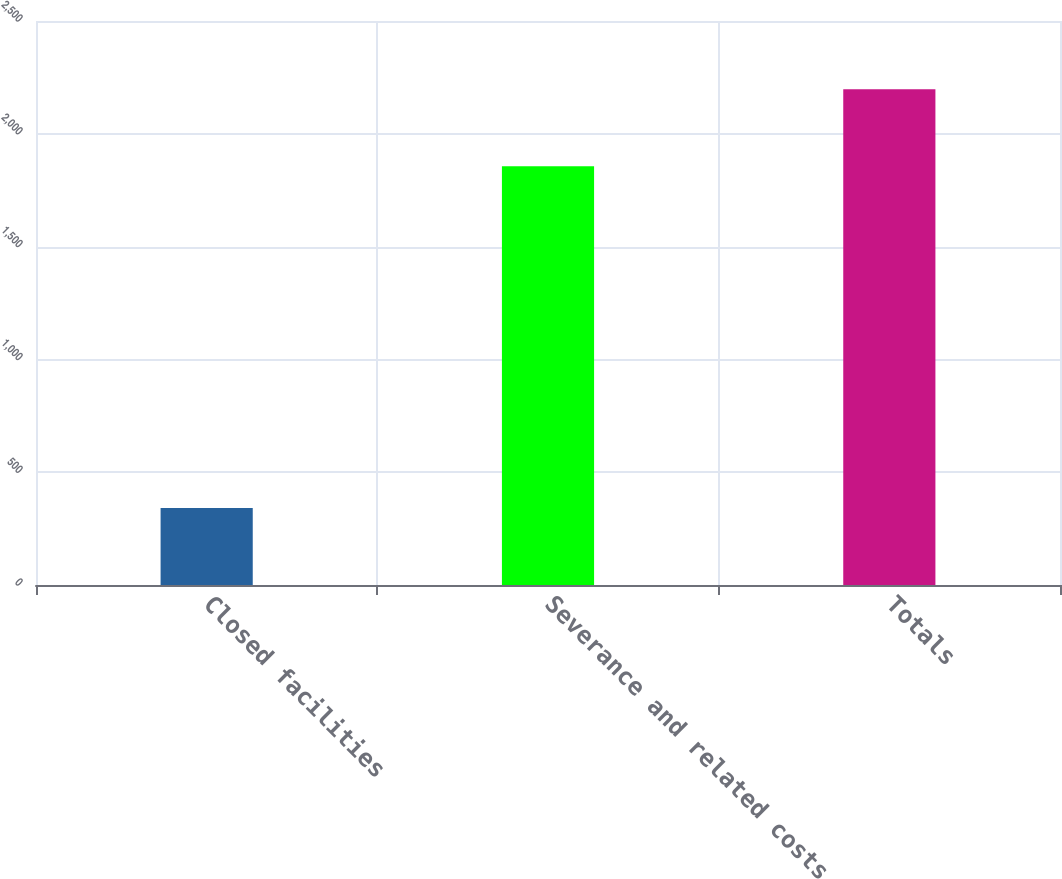Convert chart. <chart><loc_0><loc_0><loc_500><loc_500><bar_chart><fcel>Closed facilities<fcel>Severance and related costs<fcel>Totals<nl><fcel>341<fcel>1856<fcel>2197<nl></chart> 